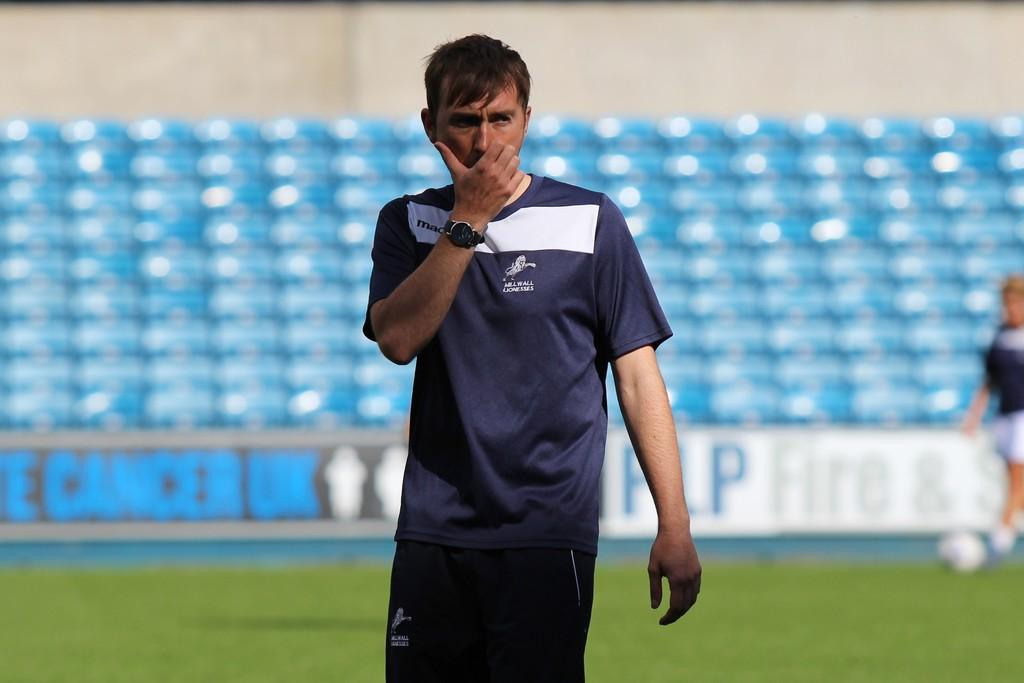Who is present in the image? There is a man in the image. What is the man wearing on his wrist? The man is wearing a watch. Can you describe the background of the image? The background of the image is blurry. What else can be seen in the background of the image? There is a person, a ball, and grass in the background of the image. What type of road can be seen in the background of the image? There is no road visible in the background of the image. Is there a camp set up in the background of the image? There is no camp present in the background of the image. 